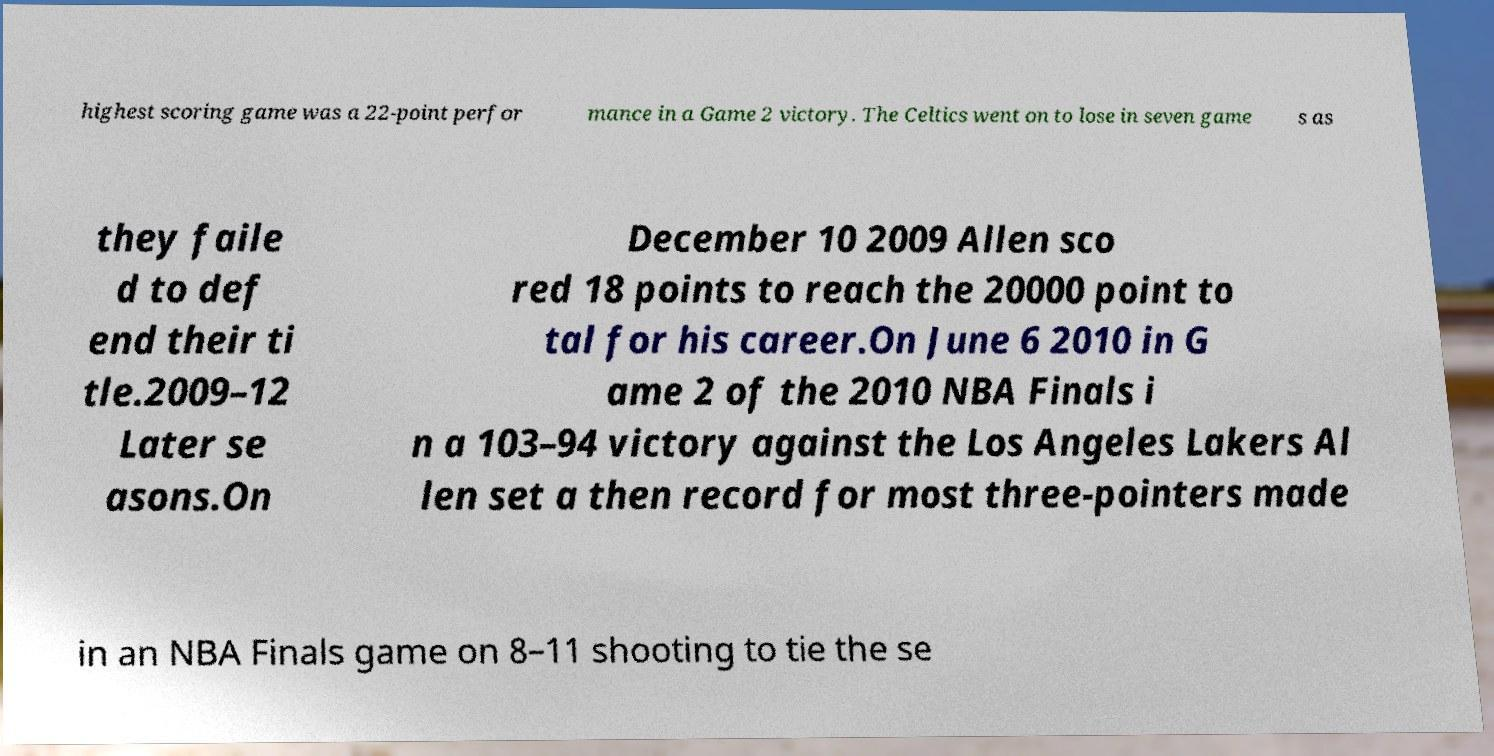Could you extract and type out the text from this image? highest scoring game was a 22-point perfor mance in a Game 2 victory. The Celtics went on to lose in seven game s as they faile d to def end their ti tle.2009–12 Later se asons.On December 10 2009 Allen sco red 18 points to reach the 20000 point to tal for his career.On June 6 2010 in G ame 2 of the 2010 NBA Finals i n a 103–94 victory against the Los Angeles Lakers Al len set a then record for most three-pointers made in an NBA Finals game on 8–11 shooting to tie the se 